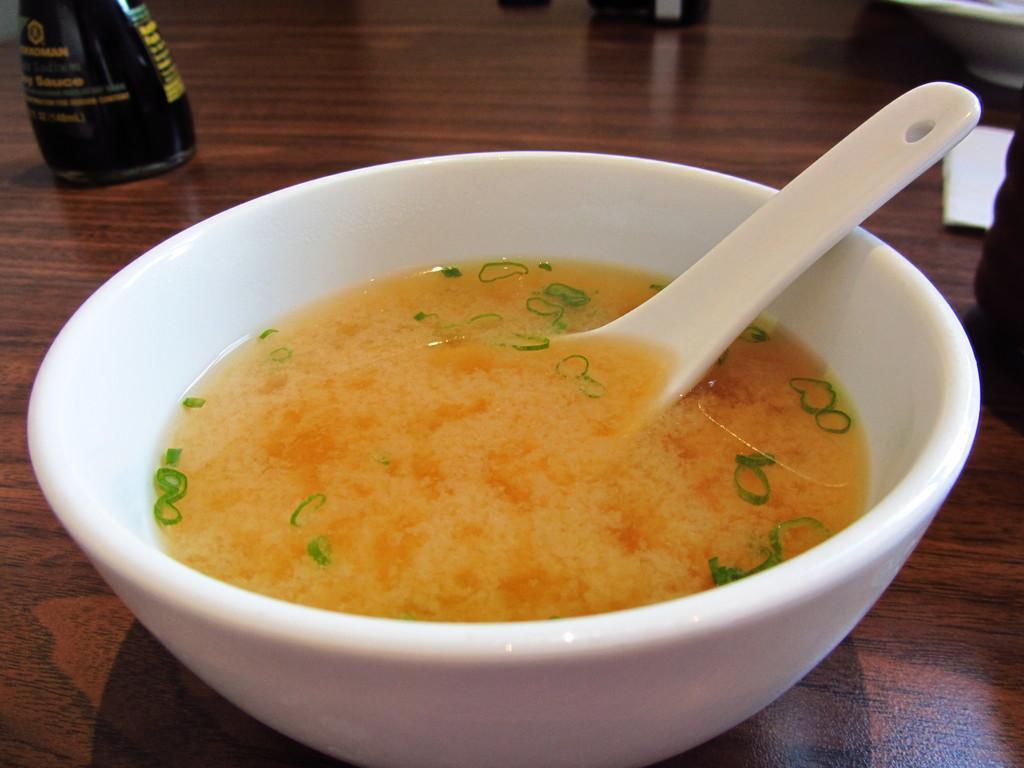Describe this image in one or two sentences. In this image I can see the bowl with some soup. The bowl is in white color and the soup is in orange color and I can also see the spoon in it. To the side there is a black color bottle and I can see few more bowls to the right. These are on the brown color table. 